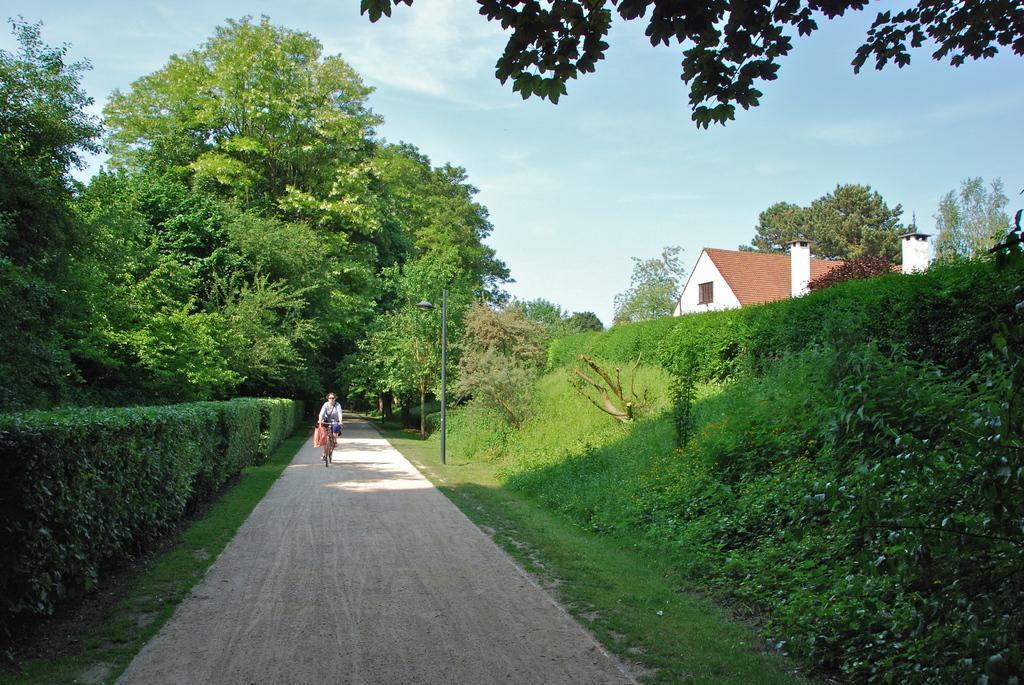Could you give a brief overview of what you see in this image? In this picture we can see a person is riding bicycle, beside the person we can find few shrubs, trees and a pole, on the right side of the image we can see a house. 